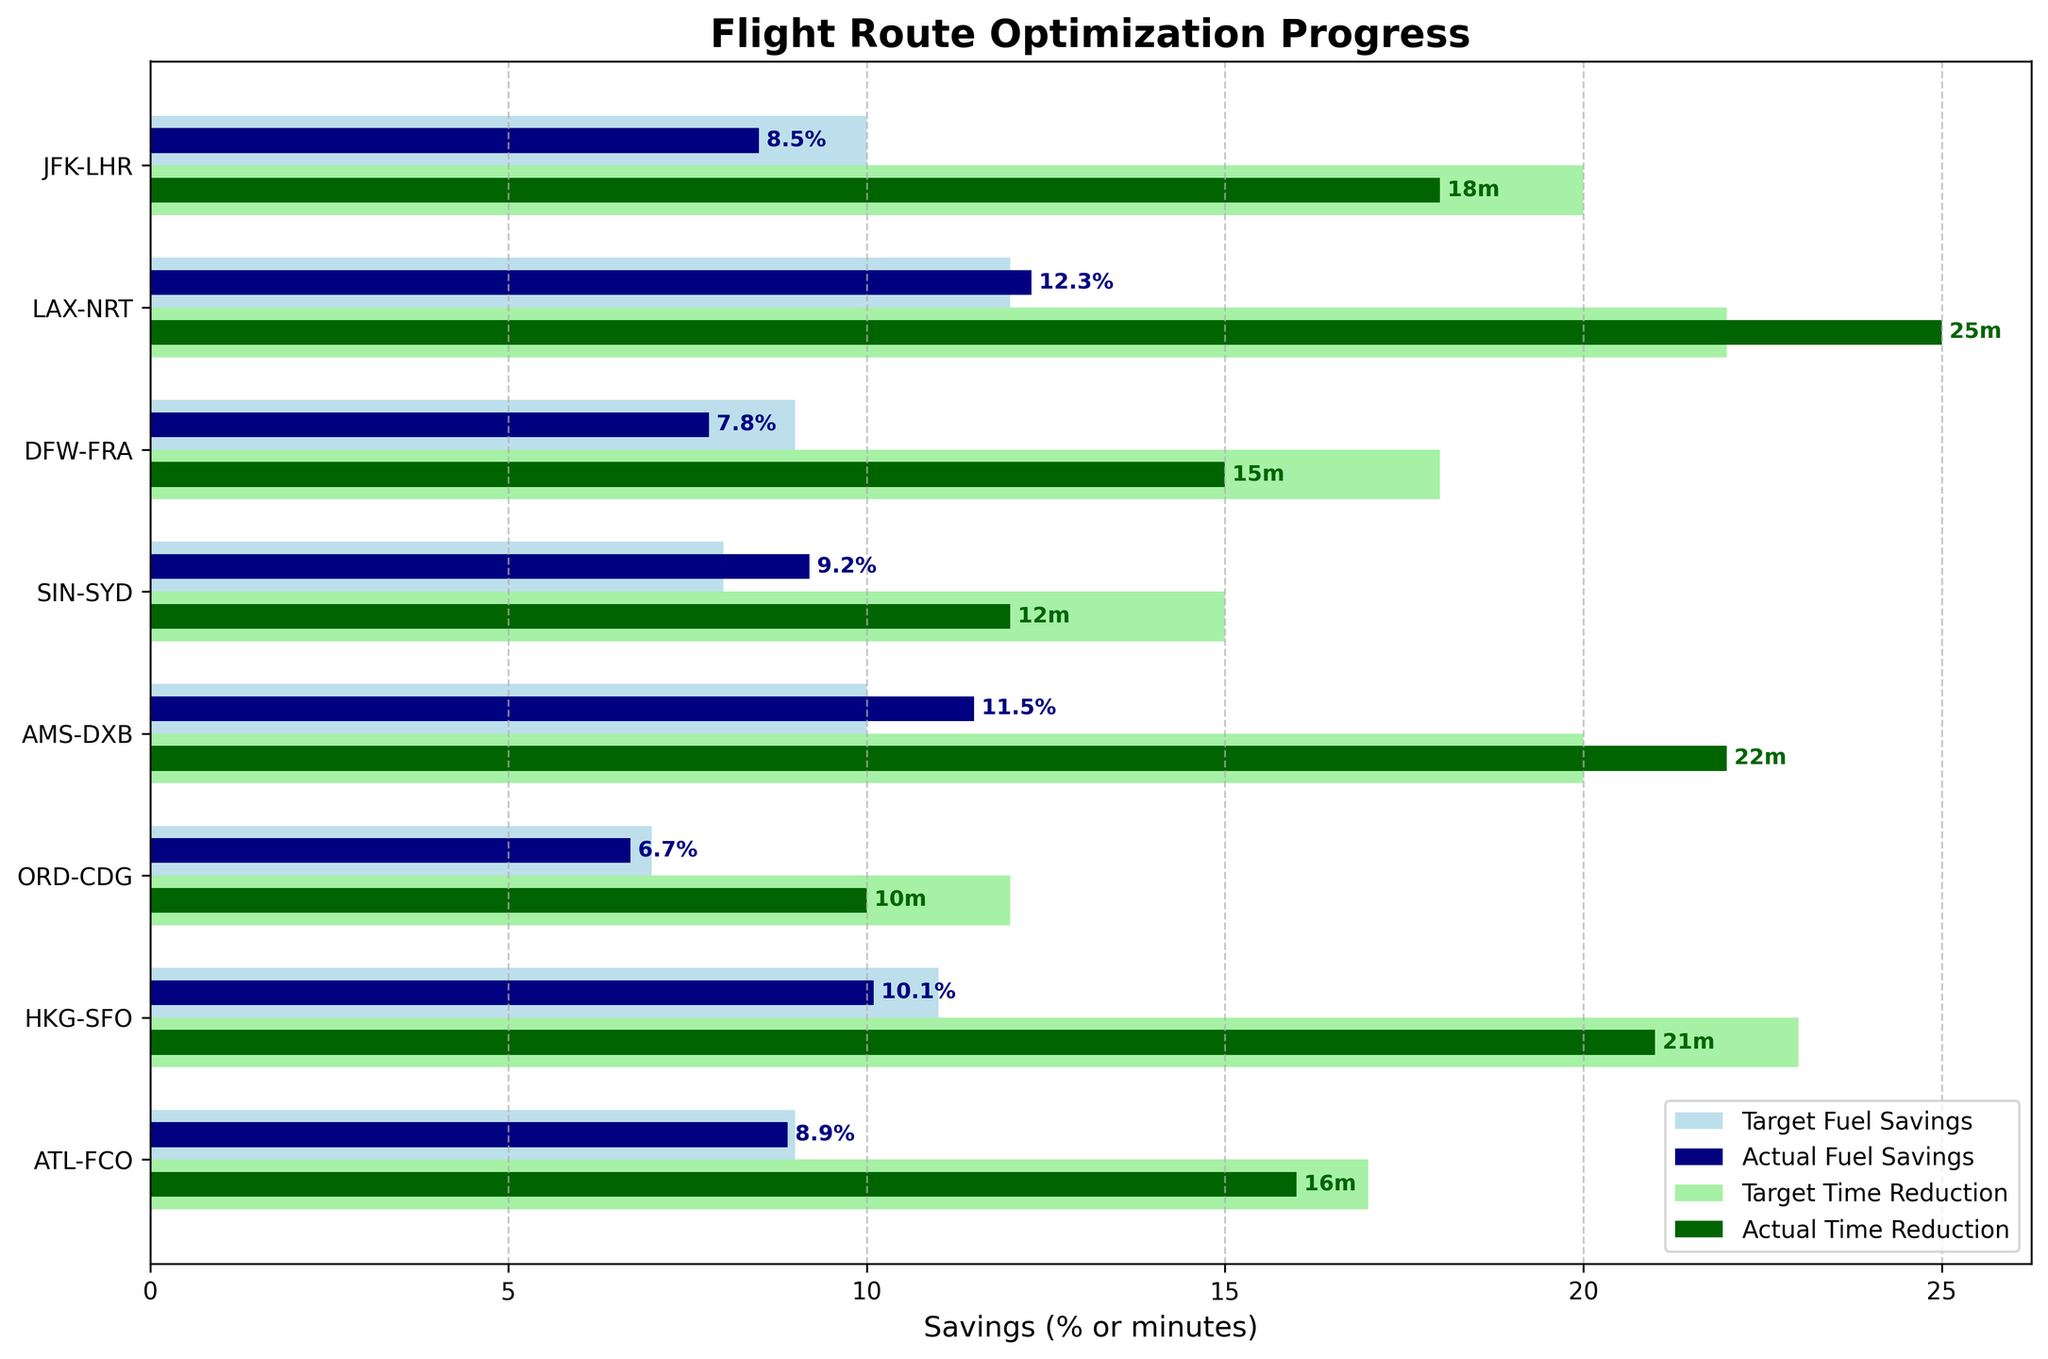What is the title of the figure? The title of the figure is displayed at the top, which summarizes the subject of the chart.
Answer: Flight Route Optimization Progress How many routes are displayed in the figure? By counting each distinct route listed on the vertical axis, we can determine the total number.
Answer: 8 What color represents the target fuel savings? The target fuel savings are represented by a specific color used consistently across all the routes.
Answer: Light blue Which route has the highest actual fuel savings percentage? By comparing the actual fuel savings percentages across all routes, we identify the highest value.
Answer: LAX-NRT How much did the JFK-LHR route save in terms of time reduction compared to its target? Subtract the actual time reduction from the target time reduction for the JFK-LHR route to find the difference.
Answer: 2 minutes Which routes met or exceeded their target fuel savings? Comparing the actual fuel savings against the target for all routes, identify those where the actual value is equal to or exceeds the target.
Answer: LAX-NRT, SIN-SYD, AMS-DXB What is the average actual time reduction across all routes? Sum the actual time reductions for each route and then divide by the number of routes to calculate the average.
Answer: 17.375 minutes How does the actual fuel savings for the ORD-CDG route compare to its target? Compare the actual fuel savings percentage with the target fuel savings percentage for the ORD-CDG route.
Answer: 0.3% below Which route shows the largest discrepancy between actual and target time reduction? Calculate the difference between actual and target time reduction for each route, and identify the largest discrepancy.
Answer: HKG-SFO For the ATL-FCO route, did the actual time reduction exceed the target? By comparing the actual time reduction with the target time reduction for this route, we determine if the actual exceeds the target.
Answer: No 